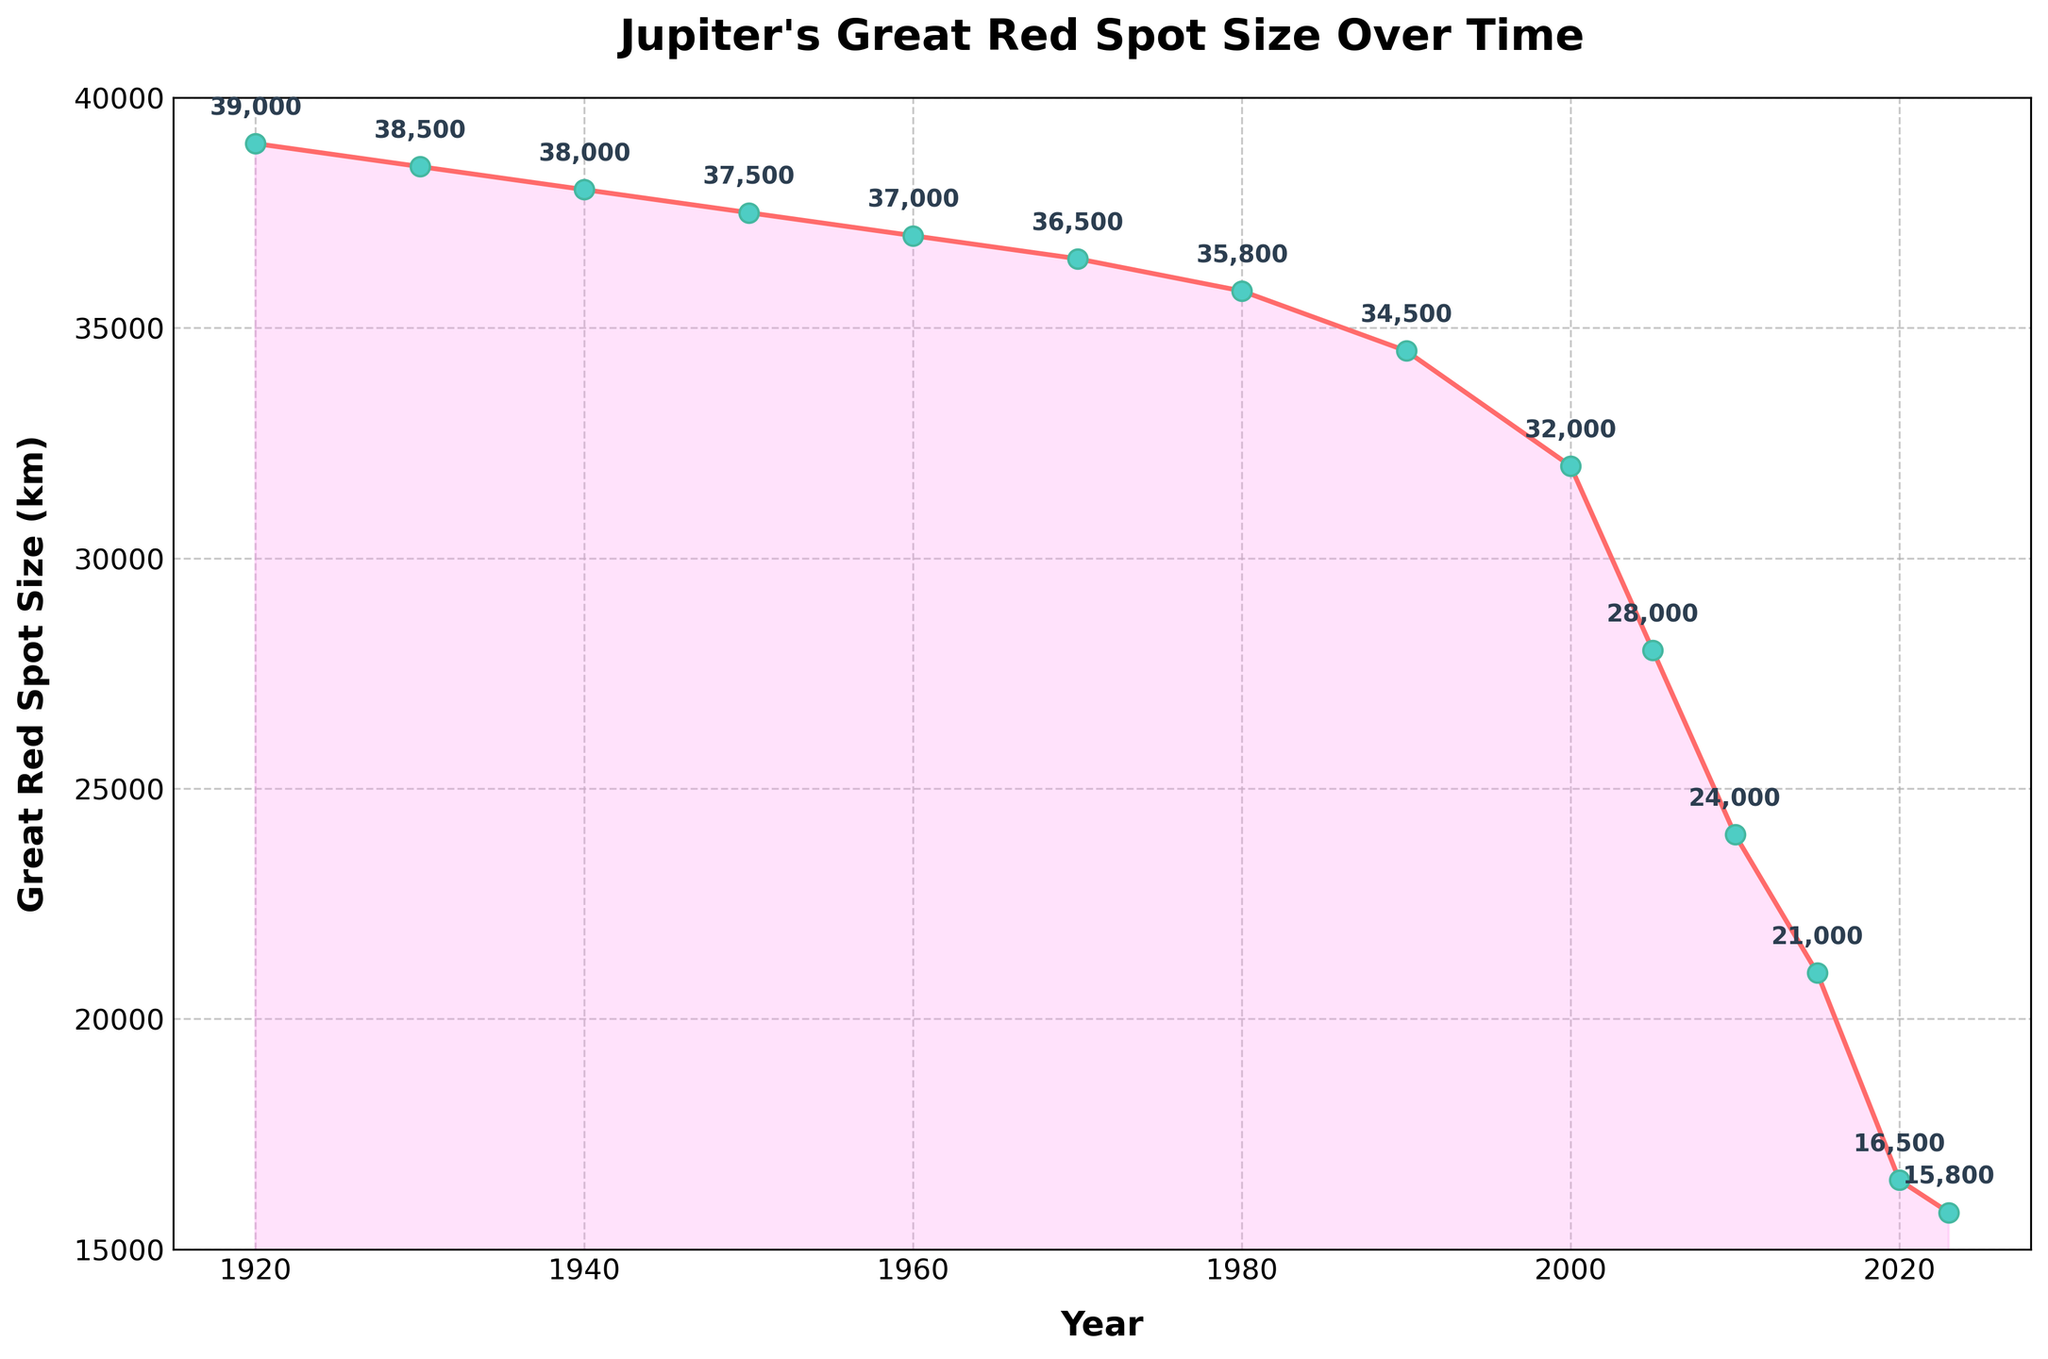What's the approximate percentage decrease in the size of Jupiter's Great Red Spot from 1920 to 2023? The size in 1920 is 39,000 km, and in 2023 it is 15,800 km. The decrease is 39,000 - 15,800 = 23,200 km. The percentage decrease is (23,200 / 39,000) * 100 ≈ 59.5%
Answer: ≈ 59.5% During which decade did the Great Red Spot experience the largest decrease in size? Compare the size differences between each decade by subtracting the value at the start of the decade from the value at the end of the decade. The largest decrease occurs between 2000 and 2010, with a change from 32,000 km to 24,000 km, i.e., 8,000 km.
Answer: 2000-2010 How does the size of the Great Red Spot in 2023 compare to its size in 1970? In 1970, the size is 36,500 km, and in 2023, it is 15,800 km. The 2023 size is significantly smaller.
Answer: It's much smaller in 2023 What is the average size of Jupiter's Great Red Spot in the 21st century (2000 to 2023)? Sum the sizes for 2000 (32,000 km), 2005 (28,000 km), 2010 (24,000 km), 2015 (21,000 km), 2020 (16,500 km), and 2023 (15,800 km): 32,000 + 28,000 + 24,000 + 21,000 + 16,500 + 15,800 = 137,300 km. There are 6 time points, so the average is 137,300 / 6 ≈ 22,883 km.
Answer: ≈ 22,883 km What was the size of the Great Red Spot in 2010, and how does it visually compare on the chart to the size in 2015? In 2010, the size is 24,000 km, and in 2015, it is 21,000 km. Visually, the point for 2015 is slightly lower than the point for 2010, indicating a decrease.
Answer: 24,000 km in 2010 and 21,000 km in 2015; the 2015 point is lower What trend can be observed in the size of the Great Red Spot from 1920 to 2023? The trend is a steady decrease in size over the years. The line graph shows a downward slope from 1920 to 2023.
Answer: A steady decrease Compare the size of the Great Red Spot in 1920 to its size in 2000. Which was larger and by how much? The size in 1920 is 39,000 km and in 2000 is 32,000 km. The 1920 size is larger by 39,000 - 32,000 = 7,000 km.
Answer: 1920 by 7,000 km What's the median size of the Great Red Spot across the given years? Order the sizes: 15,800, 16,500, 21,000, 24,000, 28,000, 32,000, 34,500, 35,800, 36,500, 37,000, 37,500, 38,000, 38,500, 39,000. The median is the average of the 7th and 8th values: (34,500 + 35,800) / 2 = 35,150 km.
Answer: 35,150 km 